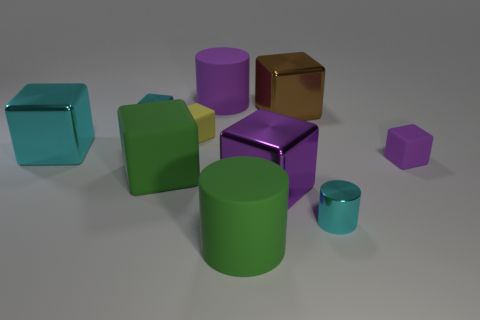Are there any big things of the same color as the big rubber cube?
Offer a terse response. Yes. What number of matte things are either tiny purple objects or big cyan things?
Your answer should be compact. 1. Are there any small blue spheres that have the same material as the yellow object?
Give a very brief answer. No. How many objects are both behind the yellow matte block and in front of the large brown block?
Give a very brief answer. 1. Are there fewer purple cylinders right of the green cylinder than tiny metallic cylinders on the left side of the yellow thing?
Give a very brief answer. No. Does the yellow thing have the same shape as the tiny purple matte object?
Ensure brevity in your answer.  Yes. What number of other objects are the same size as the green cylinder?
Ensure brevity in your answer.  5. How many objects are either small shiny objects left of the large brown metal cube or cubes that are in front of the small yellow matte cube?
Your response must be concise. 5. How many cyan metallic objects have the same shape as the brown shiny thing?
Give a very brief answer. 2. What is the thing that is both behind the yellow object and on the left side of the small yellow block made of?
Your answer should be compact. Metal. 